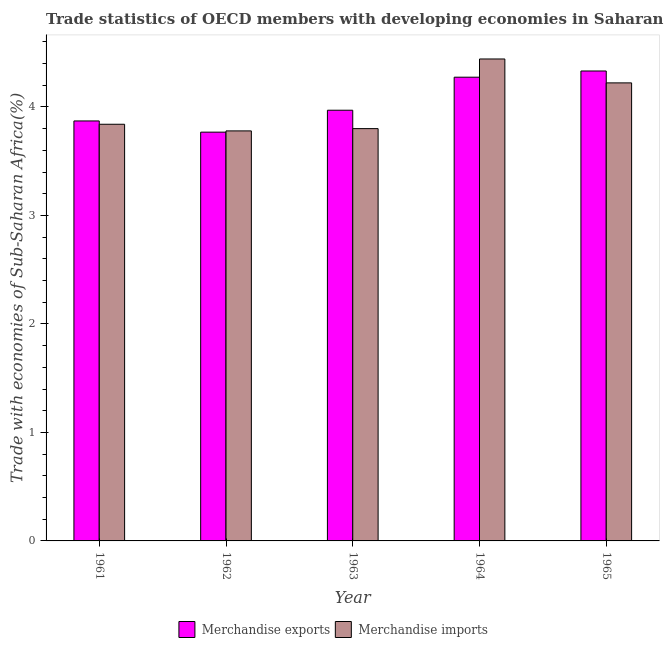How many different coloured bars are there?
Your response must be concise. 2. How many groups of bars are there?
Your answer should be compact. 5. Are the number of bars per tick equal to the number of legend labels?
Make the answer very short. Yes. How many bars are there on the 3rd tick from the left?
Provide a succinct answer. 2. How many bars are there on the 1st tick from the right?
Your response must be concise. 2. In how many cases, is the number of bars for a given year not equal to the number of legend labels?
Offer a terse response. 0. What is the merchandise exports in 1963?
Give a very brief answer. 3.97. Across all years, what is the maximum merchandise imports?
Give a very brief answer. 4.44. Across all years, what is the minimum merchandise exports?
Give a very brief answer. 3.77. In which year was the merchandise exports maximum?
Offer a terse response. 1965. What is the total merchandise imports in the graph?
Ensure brevity in your answer.  20.08. What is the difference between the merchandise imports in 1964 and that in 1965?
Offer a very short reply. 0.22. What is the difference between the merchandise exports in 1962 and the merchandise imports in 1964?
Provide a short and direct response. -0.51. What is the average merchandise imports per year?
Give a very brief answer. 4.02. In the year 1961, what is the difference between the merchandise imports and merchandise exports?
Ensure brevity in your answer.  0. In how many years, is the merchandise exports greater than 3.8 %?
Provide a succinct answer. 4. What is the ratio of the merchandise imports in 1963 to that in 1964?
Your response must be concise. 0.86. Is the difference between the merchandise exports in 1964 and 1965 greater than the difference between the merchandise imports in 1964 and 1965?
Offer a terse response. No. What is the difference between the highest and the second highest merchandise imports?
Your answer should be very brief. 0.22. What is the difference between the highest and the lowest merchandise imports?
Your answer should be very brief. 0.66. How many bars are there?
Your answer should be compact. 10. How many years are there in the graph?
Your answer should be very brief. 5. What is the title of the graph?
Offer a terse response. Trade statistics of OECD members with developing economies in Saharan Africa. Does "Male entrants" appear as one of the legend labels in the graph?
Keep it short and to the point. No. What is the label or title of the Y-axis?
Your answer should be compact. Trade with economies of Sub-Saharan Africa(%). What is the Trade with economies of Sub-Saharan Africa(%) of Merchandise exports in 1961?
Make the answer very short. 3.87. What is the Trade with economies of Sub-Saharan Africa(%) in Merchandise imports in 1961?
Provide a succinct answer. 3.84. What is the Trade with economies of Sub-Saharan Africa(%) of Merchandise exports in 1962?
Offer a terse response. 3.77. What is the Trade with economies of Sub-Saharan Africa(%) of Merchandise imports in 1962?
Offer a very short reply. 3.78. What is the Trade with economies of Sub-Saharan Africa(%) in Merchandise exports in 1963?
Offer a very short reply. 3.97. What is the Trade with economies of Sub-Saharan Africa(%) in Merchandise imports in 1963?
Your answer should be compact. 3.8. What is the Trade with economies of Sub-Saharan Africa(%) in Merchandise exports in 1964?
Keep it short and to the point. 4.27. What is the Trade with economies of Sub-Saharan Africa(%) of Merchandise imports in 1964?
Ensure brevity in your answer.  4.44. What is the Trade with economies of Sub-Saharan Africa(%) in Merchandise exports in 1965?
Offer a terse response. 4.33. What is the Trade with economies of Sub-Saharan Africa(%) of Merchandise imports in 1965?
Provide a succinct answer. 4.22. Across all years, what is the maximum Trade with economies of Sub-Saharan Africa(%) of Merchandise exports?
Make the answer very short. 4.33. Across all years, what is the maximum Trade with economies of Sub-Saharan Africa(%) in Merchandise imports?
Give a very brief answer. 4.44. Across all years, what is the minimum Trade with economies of Sub-Saharan Africa(%) in Merchandise exports?
Provide a succinct answer. 3.77. Across all years, what is the minimum Trade with economies of Sub-Saharan Africa(%) of Merchandise imports?
Offer a terse response. 3.78. What is the total Trade with economies of Sub-Saharan Africa(%) in Merchandise exports in the graph?
Provide a short and direct response. 20.22. What is the total Trade with economies of Sub-Saharan Africa(%) in Merchandise imports in the graph?
Offer a terse response. 20.08. What is the difference between the Trade with economies of Sub-Saharan Africa(%) of Merchandise exports in 1961 and that in 1962?
Your answer should be compact. 0.1. What is the difference between the Trade with economies of Sub-Saharan Africa(%) in Merchandise imports in 1961 and that in 1962?
Provide a succinct answer. 0.06. What is the difference between the Trade with economies of Sub-Saharan Africa(%) of Merchandise exports in 1961 and that in 1963?
Your answer should be compact. -0.1. What is the difference between the Trade with economies of Sub-Saharan Africa(%) in Merchandise imports in 1961 and that in 1963?
Give a very brief answer. 0.04. What is the difference between the Trade with economies of Sub-Saharan Africa(%) of Merchandise exports in 1961 and that in 1964?
Your answer should be compact. -0.4. What is the difference between the Trade with economies of Sub-Saharan Africa(%) in Merchandise imports in 1961 and that in 1964?
Ensure brevity in your answer.  -0.6. What is the difference between the Trade with economies of Sub-Saharan Africa(%) of Merchandise exports in 1961 and that in 1965?
Your answer should be compact. -0.46. What is the difference between the Trade with economies of Sub-Saharan Africa(%) in Merchandise imports in 1961 and that in 1965?
Your response must be concise. -0.38. What is the difference between the Trade with economies of Sub-Saharan Africa(%) in Merchandise exports in 1962 and that in 1963?
Ensure brevity in your answer.  -0.2. What is the difference between the Trade with economies of Sub-Saharan Africa(%) in Merchandise imports in 1962 and that in 1963?
Keep it short and to the point. -0.02. What is the difference between the Trade with economies of Sub-Saharan Africa(%) in Merchandise exports in 1962 and that in 1964?
Provide a succinct answer. -0.51. What is the difference between the Trade with economies of Sub-Saharan Africa(%) of Merchandise imports in 1962 and that in 1964?
Your response must be concise. -0.66. What is the difference between the Trade with economies of Sub-Saharan Africa(%) in Merchandise exports in 1962 and that in 1965?
Your answer should be compact. -0.56. What is the difference between the Trade with economies of Sub-Saharan Africa(%) of Merchandise imports in 1962 and that in 1965?
Your response must be concise. -0.44. What is the difference between the Trade with economies of Sub-Saharan Africa(%) of Merchandise exports in 1963 and that in 1964?
Keep it short and to the point. -0.3. What is the difference between the Trade with economies of Sub-Saharan Africa(%) of Merchandise imports in 1963 and that in 1964?
Keep it short and to the point. -0.64. What is the difference between the Trade with economies of Sub-Saharan Africa(%) in Merchandise exports in 1963 and that in 1965?
Your answer should be compact. -0.36. What is the difference between the Trade with economies of Sub-Saharan Africa(%) in Merchandise imports in 1963 and that in 1965?
Keep it short and to the point. -0.42. What is the difference between the Trade with economies of Sub-Saharan Africa(%) in Merchandise exports in 1964 and that in 1965?
Provide a succinct answer. -0.06. What is the difference between the Trade with economies of Sub-Saharan Africa(%) in Merchandise imports in 1964 and that in 1965?
Give a very brief answer. 0.22. What is the difference between the Trade with economies of Sub-Saharan Africa(%) in Merchandise exports in 1961 and the Trade with economies of Sub-Saharan Africa(%) in Merchandise imports in 1962?
Offer a terse response. 0.09. What is the difference between the Trade with economies of Sub-Saharan Africa(%) in Merchandise exports in 1961 and the Trade with economies of Sub-Saharan Africa(%) in Merchandise imports in 1963?
Ensure brevity in your answer.  0.07. What is the difference between the Trade with economies of Sub-Saharan Africa(%) in Merchandise exports in 1961 and the Trade with economies of Sub-Saharan Africa(%) in Merchandise imports in 1964?
Ensure brevity in your answer.  -0.57. What is the difference between the Trade with economies of Sub-Saharan Africa(%) of Merchandise exports in 1961 and the Trade with economies of Sub-Saharan Africa(%) of Merchandise imports in 1965?
Your answer should be very brief. -0.35. What is the difference between the Trade with economies of Sub-Saharan Africa(%) in Merchandise exports in 1962 and the Trade with economies of Sub-Saharan Africa(%) in Merchandise imports in 1963?
Provide a succinct answer. -0.03. What is the difference between the Trade with economies of Sub-Saharan Africa(%) of Merchandise exports in 1962 and the Trade with economies of Sub-Saharan Africa(%) of Merchandise imports in 1964?
Provide a succinct answer. -0.67. What is the difference between the Trade with economies of Sub-Saharan Africa(%) of Merchandise exports in 1962 and the Trade with economies of Sub-Saharan Africa(%) of Merchandise imports in 1965?
Make the answer very short. -0.45. What is the difference between the Trade with economies of Sub-Saharan Africa(%) in Merchandise exports in 1963 and the Trade with economies of Sub-Saharan Africa(%) in Merchandise imports in 1964?
Make the answer very short. -0.47. What is the difference between the Trade with economies of Sub-Saharan Africa(%) of Merchandise exports in 1963 and the Trade with economies of Sub-Saharan Africa(%) of Merchandise imports in 1965?
Give a very brief answer. -0.25. What is the difference between the Trade with economies of Sub-Saharan Africa(%) in Merchandise exports in 1964 and the Trade with economies of Sub-Saharan Africa(%) in Merchandise imports in 1965?
Your response must be concise. 0.05. What is the average Trade with economies of Sub-Saharan Africa(%) in Merchandise exports per year?
Ensure brevity in your answer.  4.04. What is the average Trade with economies of Sub-Saharan Africa(%) in Merchandise imports per year?
Your answer should be compact. 4.02. In the year 1961, what is the difference between the Trade with economies of Sub-Saharan Africa(%) in Merchandise exports and Trade with economies of Sub-Saharan Africa(%) in Merchandise imports?
Make the answer very short. 0.03. In the year 1962, what is the difference between the Trade with economies of Sub-Saharan Africa(%) of Merchandise exports and Trade with economies of Sub-Saharan Africa(%) of Merchandise imports?
Provide a short and direct response. -0.01. In the year 1963, what is the difference between the Trade with economies of Sub-Saharan Africa(%) in Merchandise exports and Trade with economies of Sub-Saharan Africa(%) in Merchandise imports?
Ensure brevity in your answer.  0.17. In the year 1964, what is the difference between the Trade with economies of Sub-Saharan Africa(%) of Merchandise exports and Trade with economies of Sub-Saharan Africa(%) of Merchandise imports?
Your response must be concise. -0.17. In the year 1965, what is the difference between the Trade with economies of Sub-Saharan Africa(%) of Merchandise exports and Trade with economies of Sub-Saharan Africa(%) of Merchandise imports?
Give a very brief answer. 0.11. What is the ratio of the Trade with economies of Sub-Saharan Africa(%) in Merchandise exports in 1961 to that in 1962?
Your answer should be compact. 1.03. What is the ratio of the Trade with economies of Sub-Saharan Africa(%) of Merchandise imports in 1961 to that in 1962?
Your answer should be compact. 1.02. What is the ratio of the Trade with economies of Sub-Saharan Africa(%) of Merchandise exports in 1961 to that in 1963?
Your answer should be compact. 0.98. What is the ratio of the Trade with economies of Sub-Saharan Africa(%) of Merchandise imports in 1961 to that in 1963?
Your answer should be very brief. 1.01. What is the ratio of the Trade with economies of Sub-Saharan Africa(%) in Merchandise exports in 1961 to that in 1964?
Offer a terse response. 0.91. What is the ratio of the Trade with economies of Sub-Saharan Africa(%) in Merchandise imports in 1961 to that in 1964?
Keep it short and to the point. 0.86. What is the ratio of the Trade with economies of Sub-Saharan Africa(%) of Merchandise exports in 1961 to that in 1965?
Offer a very short reply. 0.89. What is the ratio of the Trade with economies of Sub-Saharan Africa(%) of Merchandise imports in 1961 to that in 1965?
Provide a succinct answer. 0.91. What is the ratio of the Trade with economies of Sub-Saharan Africa(%) in Merchandise exports in 1962 to that in 1963?
Keep it short and to the point. 0.95. What is the ratio of the Trade with economies of Sub-Saharan Africa(%) in Merchandise exports in 1962 to that in 1964?
Offer a terse response. 0.88. What is the ratio of the Trade with economies of Sub-Saharan Africa(%) in Merchandise imports in 1962 to that in 1964?
Your answer should be very brief. 0.85. What is the ratio of the Trade with economies of Sub-Saharan Africa(%) in Merchandise exports in 1962 to that in 1965?
Give a very brief answer. 0.87. What is the ratio of the Trade with economies of Sub-Saharan Africa(%) in Merchandise imports in 1962 to that in 1965?
Provide a succinct answer. 0.9. What is the ratio of the Trade with economies of Sub-Saharan Africa(%) in Merchandise exports in 1963 to that in 1964?
Make the answer very short. 0.93. What is the ratio of the Trade with economies of Sub-Saharan Africa(%) of Merchandise imports in 1963 to that in 1964?
Keep it short and to the point. 0.86. What is the ratio of the Trade with economies of Sub-Saharan Africa(%) in Merchandise exports in 1963 to that in 1965?
Your answer should be very brief. 0.92. What is the ratio of the Trade with economies of Sub-Saharan Africa(%) of Merchandise imports in 1963 to that in 1965?
Give a very brief answer. 0.9. What is the ratio of the Trade with economies of Sub-Saharan Africa(%) in Merchandise exports in 1964 to that in 1965?
Ensure brevity in your answer.  0.99. What is the ratio of the Trade with economies of Sub-Saharan Africa(%) of Merchandise imports in 1964 to that in 1965?
Make the answer very short. 1.05. What is the difference between the highest and the second highest Trade with economies of Sub-Saharan Africa(%) in Merchandise exports?
Offer a terse response. 0.06. What is the difference between the highest and the second highest Trade with economies of Sub-Saharan Africa(%) in Merchandise imports?
Offer a terse response. 0.22. What is the difference between the highest and the lowest Trade with economies of Sub-Saharan Africa(%) in Merchandise exports?
Ensure brevity in your answer.  0.56. What is the difference between the highest and the lowest Trade with economies of Sub-Saharan Africa(%) in Merchandise imports?
Your response must be concise. 0.66. 